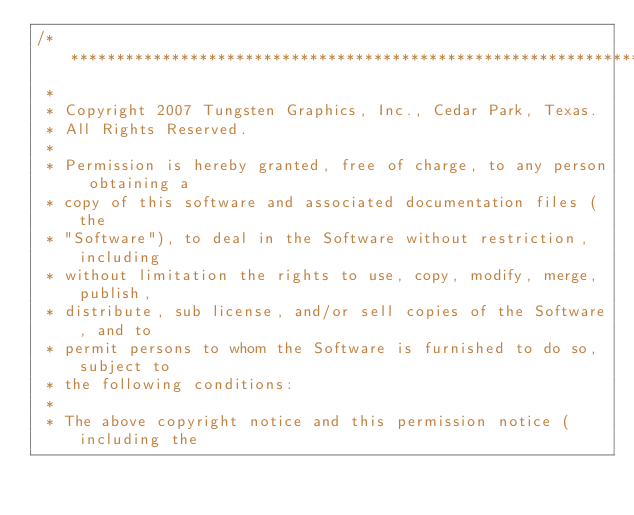Convert code to text. <code><loc_0><loc_0><loc_500><loc_500><_C_>/**************************************************************************
 * 
 * Copyright 2007 Tungsten Graphics, Inc., Cedar Park, Texas.
 * All Rights Reserved.
 * 
 * Permission is hereby granted, free of charge, to any person obtaining a
 * copy of this software and associated documentation files (the
 * "Software"), to deal in the Software without restriction, including
 * without limitation the rights to use, copy, modify, merge, publish,
 * distribute, sub license, and/or sell copies of the Software, and to
 * permit persons to whom the Software is furnished to do so, subject to
 * the following conditions:
 * 
 * The above copyright notice and this permission notice (including the</code> 